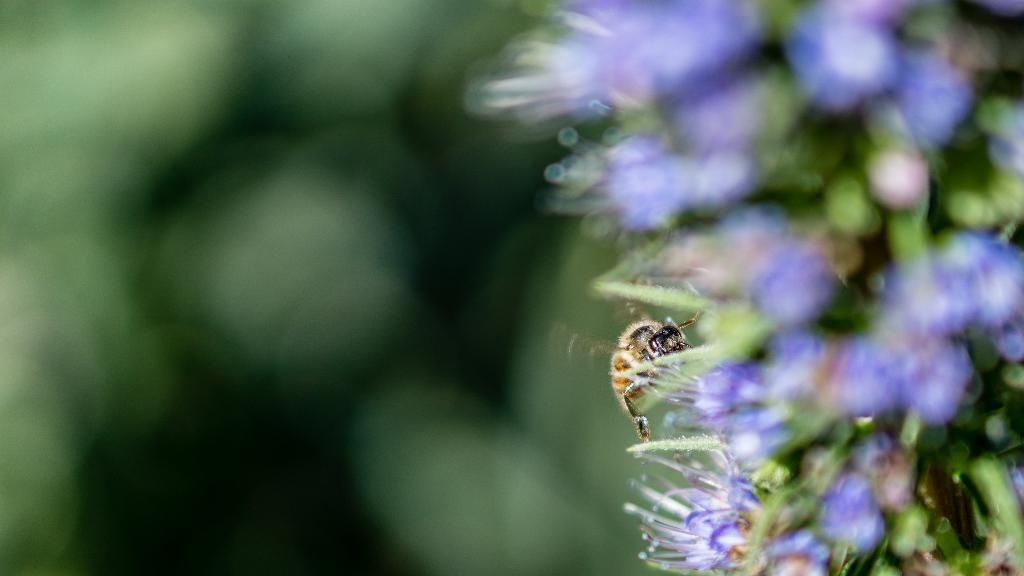What is present in the image? There is an insect in the image. Where is the insect located? The insect is on flowers. Can you describe the background of the image? The background of the image is blurry. What type of crayon is being used to draw on the vessel in the image? There is no crayon or vessel present in the image; it features an insect on flowers with a blurry background. 